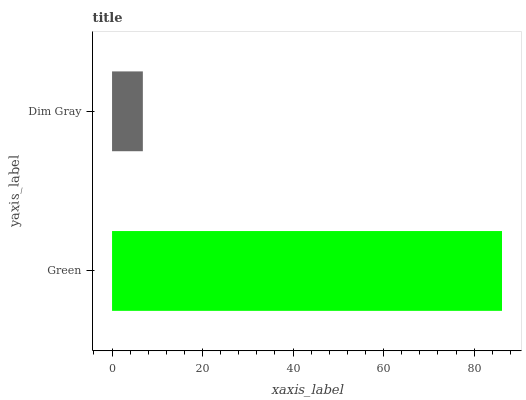Is Dim Gray the minimum?
Answer yes or no. Yes. Is Green the maximum?
Answer yes or no. Yes. Is Dim Gray the maximum?
Answer yes or no. No. Is Green greater than Dim Gray?
Answer yes or no. Yes. Is Dim Gray less than Green?
Answer yes or no. Yes. Is Dim Gray greater than Green?
Answer yes or no. No. Is Green less than Dim Gray?
Answer yes or no. No. Is Green the high median?
Answer yes or no. Yes. Is Dim Gray the low median?
Answer yes or no. Yes. Is Dim Gray the high median?
Answer yes or no. No. Is Green the low median?
Answer yes or no. No. 